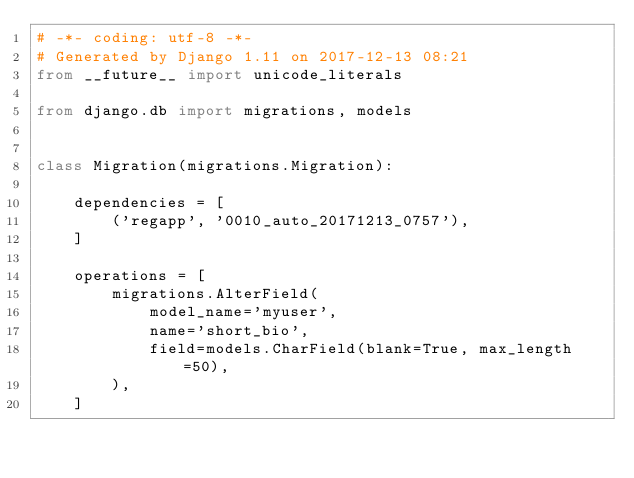<code> <loc_0><loc_0><loc_500><loc_500><_Python_># -*- coding: utf-8 -*-
# Generated by Django 1.11 on 2017-12-13 08:21
from __future__ import unicode_literals

from django.db import migrations, models


class Migration(migrations.Migration):

    dependencies = [
        ('regapp', '0010_auto_20171213_0757'),
    ]

    operations = [
        migrations.AlterField(
            model_name='myuser',
            name='short_bio',
            field=models.CharField(blank=True, max_length=50),
        ),
    ]
</code> 